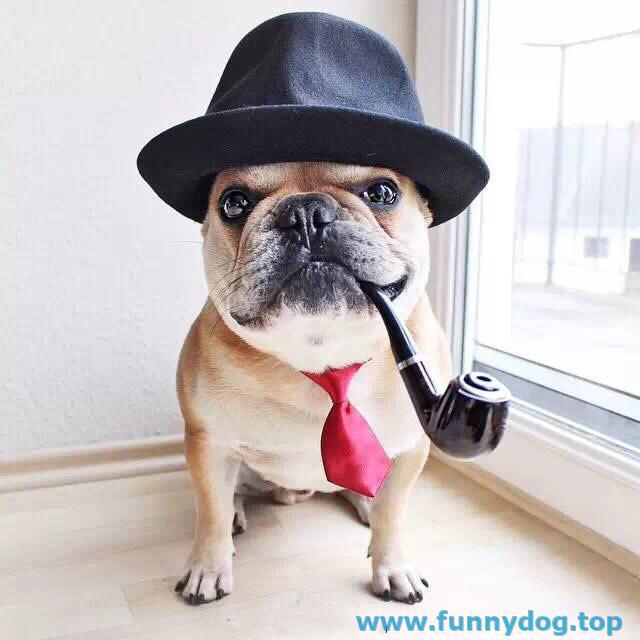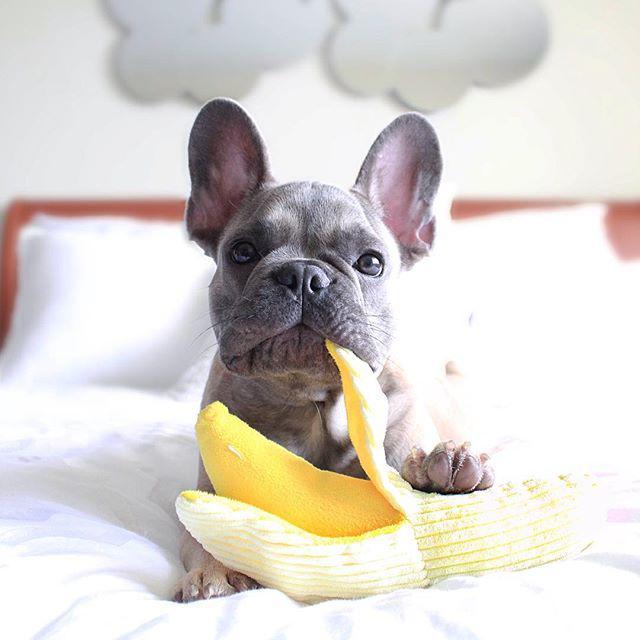The first image is the image on the left, the second image is the image on the right. Considering the images on both sides, is "One image shows a dog with its face near a peeled banana shape." valid? Answer yes or no. Yes. The first image is the image on the left, the second image is the image on the right. Evaluate the accuracy of this statement regarding the images: "One image features a dog next to a half-peeled banana.". Is it true? Answer yes or no. Yes. 